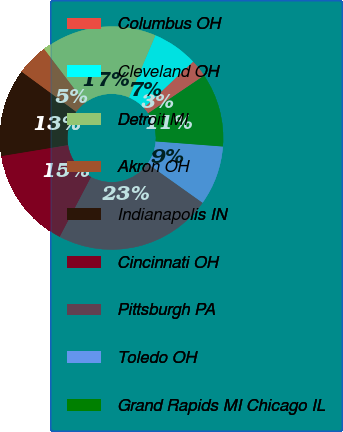Convert chart. <chart><loc_0><loc_0><loc_500><loc_500><pie_chart><fcel>Columbus OH<fcel>Cleveland OH<fcel>Detroit MI<fcel>Akron OH<fcel>Indianapolis IN<fcel>Cincinnati OH<fcel>Pittsburgh PA<fcel>Toledo OH<fcel>Grand Rapids MI Chicago IL<nl><fcel>2.54%<fcel>6.6%<fcel>16.75%<fcel>4.57%<fcel>12.69%<fcel>14.72%<fcel>22.84%<fcel>8.63%<fcel>10.66%<nl></chart> 